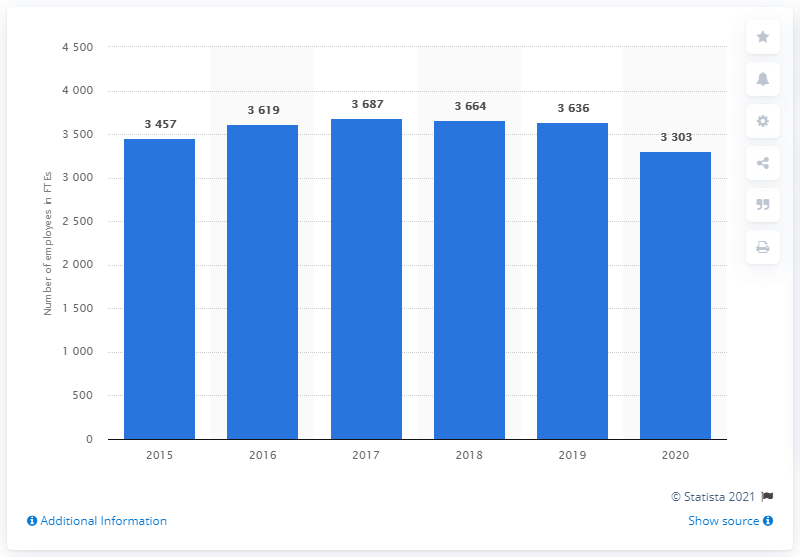Specify some key components in this picture. In the year that followed 2015, the number of employees at Barco increased. 